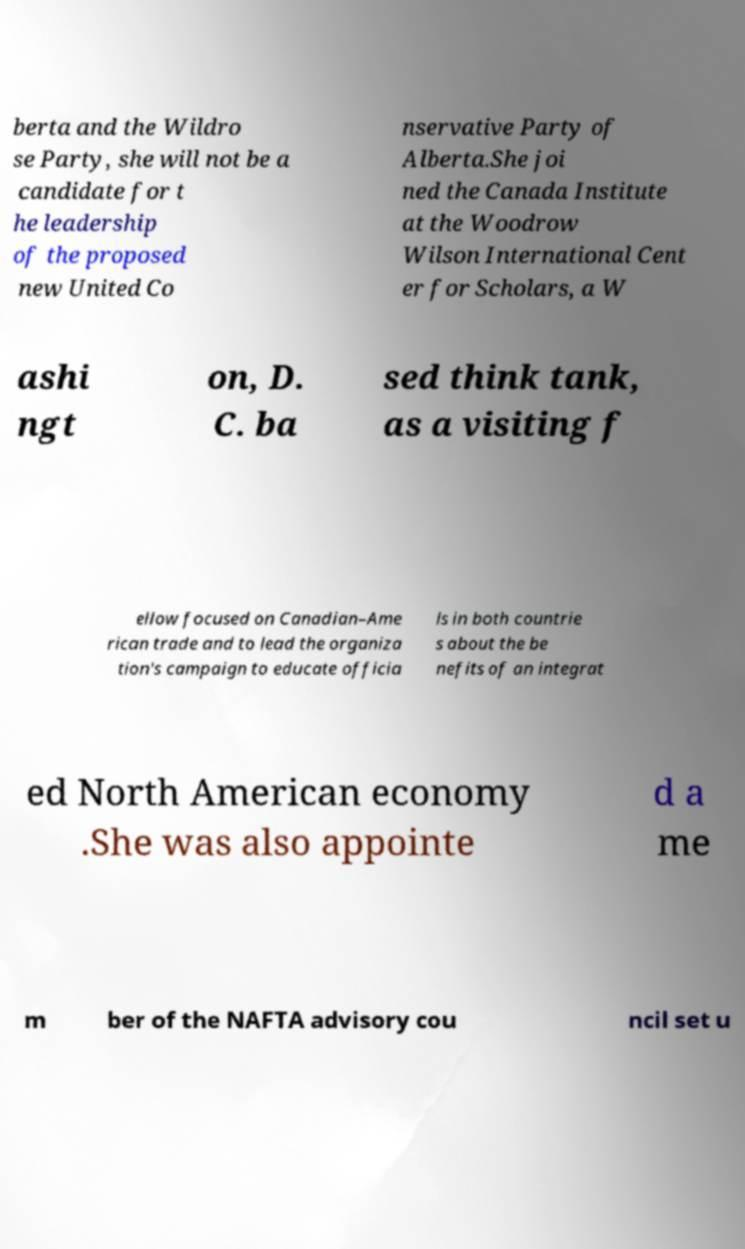Please identify and transcribe the text found in this image. berta and the Wildro se Party, she will not be a candidate for t he leadership of the proposed new United Co nservative Party of Alberta.She joi ned the Canada Institute at the Woodrow Wilson International Cent er for Scholars, a W ashi ngt on, D. C. ba sed think tank, as a visiting f ellow focused on Canadian–Ame rican trade and to lead the organiza tion's campaign to educate officia ls in both countrie s about the be nefits of an integrat ed North American economy .She was also appointe d a me m ber of the NAFTA advisory cou ncil set u 